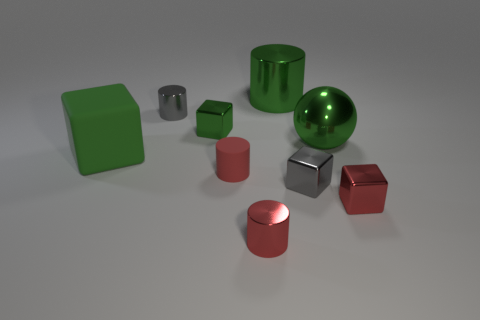How many big metal cylinders have the same color as the big matte block?
Provide a succinct answer. 1. There is a tiny cube that is the same color as the big sphere; what is it made of?
Give a very brief answer. Metal. What number of things are either tiny red cylinders or small red metallic things?
Make the answer very short. 3. There is a gray object to the right of the green shiny cylinder; is its size the same as the green cube to the left of the tiny gray metal cylinder?
Provide a succinct answer. No. What number of spheres are small green metallic things or green things?
Keep it short and to the point. 1. Is there a metallic cylinder?
Provide a short and direct response. Yes. Is there anything else that has the same shape as the small green object?
Give a very brief answer. Yes. Is the color of the matte block the same as the big ball?
Your response must be concise. Yes. What number of things are tiny red objects to the left of the big cylinder or green metal balls?
Give a very brief answer. 3. How many small shiny things are on the right side of the tiny metallic cylinder that is behind the tiny red shiny thing that is right of the big green sphere?
Your response must be concise. 4. 